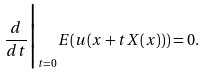Convert formula to latex. <formula><loc_0><loc_0><loc_500><loc_500>\frac { d } { d t } \Big | _ { t = 0 } E ( u ( x + t X ( x ) ) ) = 0 .</formula> 